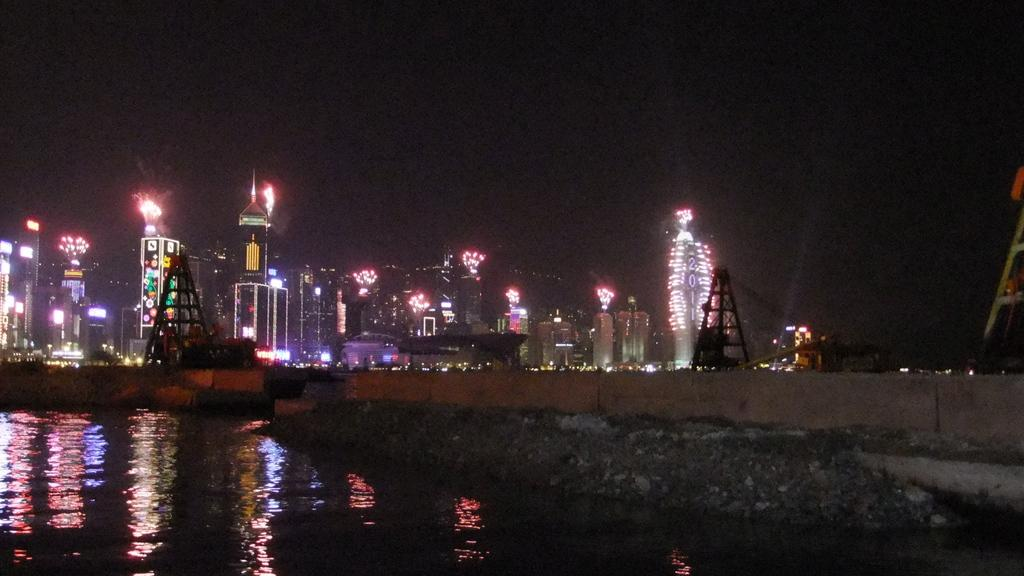What is the main feature of the image? The main feature of the image is water. What structures can be seen in the image? There is a bridge, buildings, and towers in the image. What else is present in the image? There are lights in the image. How would you describe the sky in the background? The sky in the background is dark. What is the reason for the mouth being closed in the image? There is no mouth present in the image, as it features water, a bridge, buildings, towers, lights, and a dark sky. 